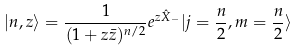<formula> <loc_0><loc_0><loc_500><loc_500>| n , z \rangle = \frac { 1 } { ( 1 + z \bar { z } ) ^ { n / 2 } } e ^ { z \hat { X } _ { - } } | j = \frac { n } { 2 } , m = \frac { n } { 2 } \rangle</formula> 